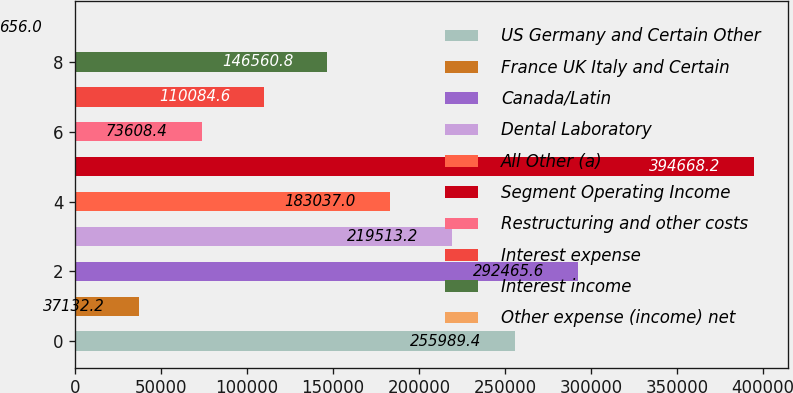<chart> <loc_0><loc_0><loc_500><loc_500><bar_chart><fcel>US Germany and Certain Other<fcel>France UK Italy and Certain<fcel>Canada/Latin<fcel>Dental Laboratory<fcel>All Other (a)<fcel>Segment Operating Income<fcel>Restructuring and other costs<fcel>Interest expense<fcel>Interest income<fcel>Other expense (income) net<nl><fcel>255989<fcel>37132.2<fcel>292466<fcel>219513<fcel>183037<fcel>394668<fcel>73608.4<fcel>110085<fcel>146561<fcel>656<nl></chart> 